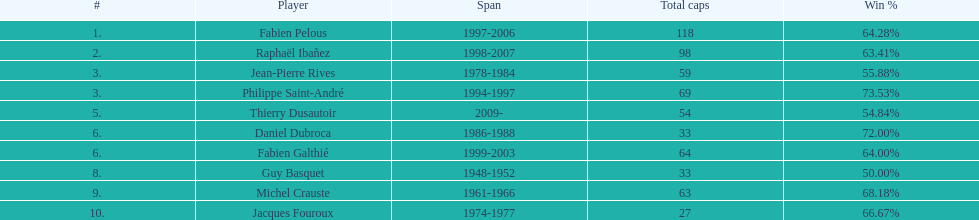For what duration did fabien pelous lead as captain in the french national rugby team? 9 years. 